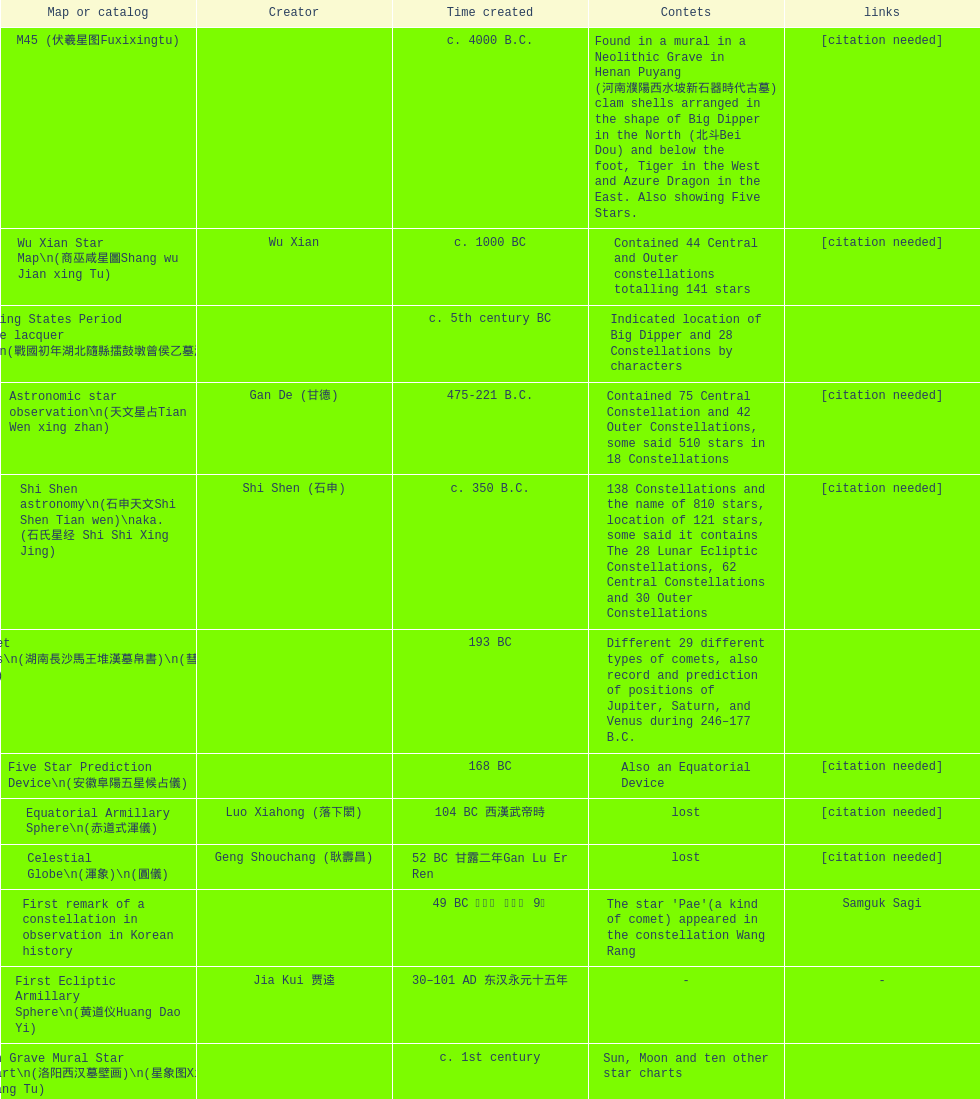Which was the earliest chinese star map acknowledged to have been made? M45 (伏羲星图Fuxixingtu). 